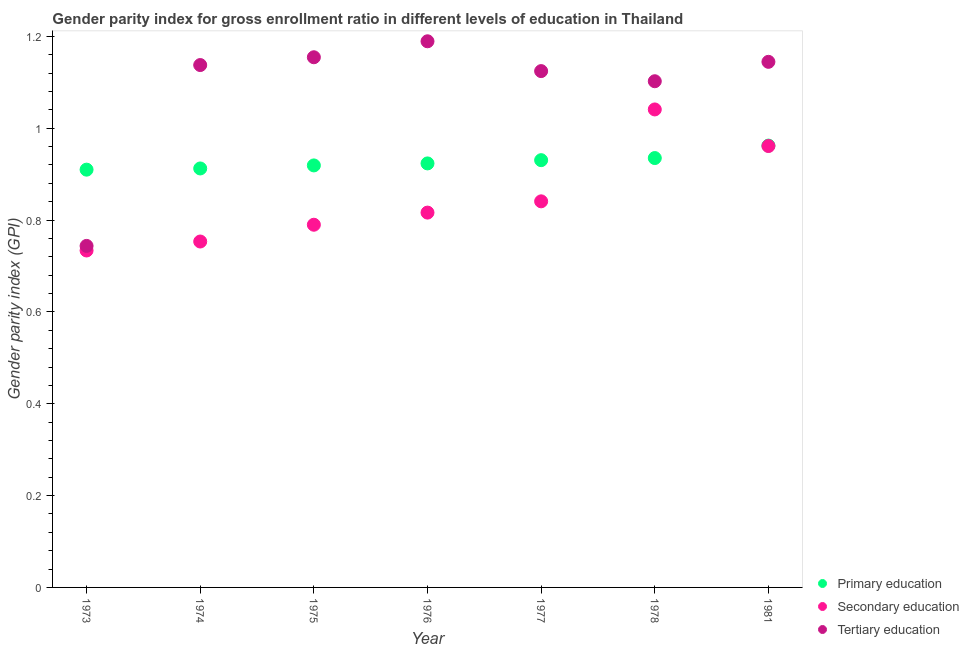How many different coloured dotlines are there?
Offer a very short reply. 3. What is the gender parity index in primary education in 1973?
Provide a succinct answer. 0.91. Across all years, what is the maximum gender parity index in primary education?
Provide a short and direct response. 0.96. Across all years, what is the minimum gender parity index in secondary education?
Offer a very short reply. 0.73. In which year was the gender parity index in primary education maximum?
Keep it short and to the point. 1981. In which year was the gender parity index in primary education minimum?
Provide a short and direct response. 1973. What is the total gender parity index in primary education in the graph?
Give a very brief answer. 6.49. What is the difference between the gender parity index in primary education in 1973 and that in 1977?
Provide a short and direct response. -0.02. What is the difference between the gender parity index in secondary education in 1976 and the gender parity index in primary education in 1973?
Your response must be concise. -0.09. What is the average gender parity index in secondary education per year?
Offer a terse response. 0.85. In the year 1976, what is the difference between the gender parity index in secondary education and gender parity index in tertiary education?
Offer a terse response. -0.37. What is the ratio of the gender parity index in secondary education in 1973 to that in 1978?
Ensure brevity in your answer.  0.7. Is the gender parity index in primary education in 1973 less than that in 1974?
Provide a short and direct response. Yes. What is the difference between the highest and the second highest gender parity index in secondary education?
Your answer should be compact. 0.08. What is the difference between the highest and the lowest gender parity index in tertiary education?
Give a very brief answer. 0.45. Is it the case that in every year, the sum of the gender parity index in primary education and gender parity index in secondary education is greater than the gender parity index in tertiary education?
Offer a terse response. Yes. Does the gender parity index in secondary education monotonically increase over the years?
Offer a very short reply. No. Is the gender parity index in secondary education strictly greater than the gender parity index in tertiary education over the years?
Your answer should be very brief. No. Is the gender parity index in primary education strictly less than the gender parity index in tertiary education over the years?
Your response must be concise. No. How many dotlines are there?
Make the answer very short. 3. What is the difference between two consecutive major ticks on the Y-axis?
Provide a succinct answer. 0.2. Are the values on the major ticks of Y-axis written in scientific E-notation?
Provide a short and direct response. No. Does the graph contain grids?
Make the answer very short. No. Where does the legend appear in the graph?
Make the answer very short. Bottom right. How are the legend labels stacked?
Keep it short and to the point. Vertical. What is the title of the graph?
Your response must be concise. Gender parity index for gross enrollment ratio in different levels of education in Thailand. What is the label or title of the Y-axis?
Offer a very short reply. Gender parity index (GPI). What is the Gender parity index (GPI) in Primary education in 1973?
Your answer should be compact. 0.91. What is the Gender parity index (GPI) of Secondary education in 1973?
Make the answer very short. 0.73. What is the Gender parity index (GPI) of Tertiary education in 1973?
Ensure brevity in your answer.  0.74. What is the Gender parity index (GPI) in Primary education in 1974?
Keep it short and to the point. 0.91. What is the Gender parity index (GPI) in Secondary education in 1974?
Ensure brevity in your answer.  0.75. What is the Gender parity index (GPI) in Tertiary education in 1974?
Give a very brief answer. 1.14. What is the Gender parity index (GPI) in Primary education in 1975?
Your answer should be very brief. 0.92. What is the Gender parity index (GPI) in Secondary education in 1975?
Provide a short and direct response. 0.79. What is the Gender parity index (GPI) of Tertiary education in 1975?
Offer a terse response. 1.15. What is the Gender parity index (GPI) in Primary education in 1976?
Make the answer very short. 0.92. What is the Gender parity index (GPI) of Secondary education in 1976?
Your answer should be compact. 0.82. What is the Gender parity index (GPI) in Tertiary education in 1976?
Keep it short and to the point. 1.19. What is the Gender parity index (GPI) of Primary education in 1977?
Offer a very short reply. 0.93. What is the Gender parity index (GPI) in Secondary education in 1977?
Offer a terse response. 0.84. What is the Gender parity index (GPI) of Tertiary education in 1977?
Provide a succinct answer. 1.12. What is the Gender parity index (GPI) of Primary education in 1978?
Make the answer very short. 0.94. What is the Gender parity index (GPI) of Secondary education in 1978?
Provide a succinct answer. 1.04. What is the Gender parity index (GPI) of Tertiary education in 1978?
Provide a succinct answer. 1.1. What is the Gender parity index (GPI) of Primary education in 1981?
Make the answer very short. 0.96. What is the Gender parity index (GPI) in Secondary education in 1981?
Give a very brief answer. 0.96. What is the Gender parity index (GPI) of Tertiary education in 1981?
Keep it short and to the point. 1.14. Across all years, what is the maximum Gender parity index (GPI) in Primary education?
Give a very brief answer. 0.96. Across all years, what is the maximum Gender parity index (GPI) in Secondary education?
Your response must be concise. 1.04. Across all years, what is the maximum Gender parity index (GPI) in Tertiary education?
Your answer should be very brief. 1.19. Across all years, what is the minimum Gender parity index (GPI) of Primary education?
Provide a succinct answer. 0.91. Across all years, what is the minimum Gender parity index (GPI) in Secondary education?
Your answer should be very brief. 0.73. Across all years, what is the minimum Gender parity index (GPI) of Tertiary education?
Provide a short and direct response. 0.74. What is the total Gender parity index (GPI) in Primary education in the graph?
Your answer should be compact. 6.49. What is the total Gender parity index (GPI) in Secondary education in the graph?
Your answer should be compact. 5.94. What is the total Gender parity index (GPI) in Tertiary education in the graph?
Offer a terse response. 7.6. What is the difference between the Gender parity index (GPI) of Primary education in 1973 and that in 1974?
Your answer should be compact. -0. What is the difference between the Gender parity index (GPI) in Secondary education in 1973 and that in 1974?
Ensure brevity in your answer.  -0.02. What is the difference between the Gender parity index (GPI) of Tertiary education in 1973 and that in 1974?
Ensure brevity in your answer.  -0.39. What is the difference between the Gender parity index (GPI) in Primary education in 1973 and that in 1975?
Offer a terse response. -0.01. What is the difference between the Gender parity index (GPI) of Secondary education in 1973 and that in 1975?
Provide a short and direct response. -0.06. What is the difference between the Gender parity index (GPI) of Tertiary education in 1973 and that in 1975?
Make the answer very short. -0.41. What is the difference between the Gender parity index (GPI) in Primary education in 1973 and that in 1976?
Keep it short and to the point. -0.01. What is the difference between the Gender parity index (GPI) of Secondary education in 1973 and that in 1976?
Provide a short and direct response. -0.08. What is the difference between the Gender parity index (GPI) in Tertiary education in 1973 and that in 1976?
Ensure brevity in your answer.  -0.45. What is the difference between the Gender parity index (GPI) of Primary education in 1973 and that in 1977?
Offer a very short reply. -0.02. What is the difference between the Gender parity index (GPI) in Secondary education in 1973 and that in 1977?
Your answer should be compact. -0.11. What is the difference between the Gender parity index (GPI) of Tertiary education in 1973 and that in 1977?
Ensure brevity in your answer.  -0.38. What is the difference between the Gender parity index (GPI) in Primary education in 1973 and that in 1978?
Provide a succinct answer. -0.03. What is the difference between the Gender parity index (GPI) in Secondary education in 1973 and that in 1978?
Your answer should be compact. -0.31. What is the difference between the Gender parity index (GPI) of Tertiary education in 1973 and that in 1978?
Offer a very short reply. -0.36. What is the difference between the Gender parity index (GPI) in Primary education in 1973 and that in 1981?
Your response must be concise. -0.05. What is the difference between the Gender parity index (GPI) of Secondary education in 1973 and that in 1981?
Give a very brief answer. -0.23. What is the difference between the Gender parity index (GPI) in Tertiary education in 1973 and that in 1981?
Ensure brevity in your answer.  -0.4. What is the difference between the Gender parity index (GPI) in Primary education in 1974 and that in 1975?
Offer a very short reply. -0.01. What is the difference between the Gender parity index (GPI) in Secondary education in 1974 and that in 1975?
Give a very brief answer. -0.04. What is the difference between the Gender parity index (GPI) of Tertiary education in 1974 and that in 1975?
Keep it short and to the point. -0.02. What is the difference between the Gender parity index (GPI) of Primary education in 1974 and that in 1976?
Your response must be concise. -0.01. What is the difference between the Gender parity index (GPI) in Secondary education in 1974 and that in 1976?
Your answer should be compact. -0.06. What is the difference between the Gender parity index (GPI) of Tertiary education in 1974 and that in 1976?
Your answer should be very brief. -0.05. What is the difference between the Gender parity index (GPI) of Primary education in 1974 and that in 1977?
Give a very brief answer. -0.02. What is the difference between the Gender parity index (GPI) of Secondary education in 1974 and that in 1977?
Offer a very short reply. -0.09. What is the difference between the Gender parity index (GPI) of Tertiary education in 1974 and that in 1977?
Provide a short and direct response. 0.01. What is the difference between the Gender parity index (GPI) of Primary education in 1974 and that in 1978?
Offer a terse response. -0.02. What is the difference between the Gender parity index (GPI) in Secondary education in 1974 and that in 1978?
Ensure brevity in your answer.  -0.29. What is the difference between the Gender parity index (GPI) in Tertiary education in 1974 and that in 1978?
Keep it short and to the point. 0.04. What is the difference between the Gender parity index (GPI) in Primary education in 1974 and that in 1981?
Ensure brevity in your answer.  -0.05. What is the difference between the Gender parity index (GPI) of Secondary education in 1974 and that in 1981?
Offer a very short reply. -0.21. What is the difference between the Gender parity index (GPI) of Tertiary education in 1974 and that in 1981?
Give a very brief answer. -0.01. What is the difference between the Gender parity index (GPI) in Primary education in 1975 and that in 1976?
Provide a succinct answer. -0. What is the difference between the Gender parity index (GPI) of Secondary education in 1975 and that in 1976?
Ensure brevity in your answer.  -0.03. What is the difference between the Gender parity index (GPI) in Tertiary education in 1975 and that in 1976?
Ensure brevity in your answer.  -0.03. What is the difference between the Gender parity index (GPI) in Primary education in 1975 and that in 1977?
Provide a short and direct response. -0.01. What is the difference between the Gender parity index (GPI) of Secondary education in 1975 and that in 1977?
Keep it short and to the point. -0.05. What is the difference between the Gender parity index (GPI) of Tertiary education in 1975 and that in 1977?
Offer a terse response. 0.03. What is the difference between the Gender parity index (GPI) in Primary education in 1975 and that in 1978?
Offer a terse response. -0.02. What is the difference between the Gender parity index (GPI) of Secondary education in 1975 and that in 1978?
Your answer should be compact. -0.25. What is the difference between the Gender parity index (GPI) of Tertiary education in 1975 and that in 1978?
Provide a succinct answer. 0.05. What is the difference between the Gender parity index (GPI) in Primary education in 1975 and that in 1981?
Offer a very short reply. -0.04. What is the difference between the Gender parity index (GPI) in Secondary education in 1975 and that in 1981?
Offer a very short reply. -0.17. What is the difference between the Gender parity index (GPI) of Tertiary education in 1975 and that in 1981?
Offer a terse response. 0.01. What is the difference between the Gender parity index (GPI) in Primary education in 1976 and that in 1977?
Provide a succinct answer. -0.01. What is the difference between the Gender parity index (GPI) in Secondary education in 1976 and that in 1977?
Make the answer very short. -0.02. What is the difference between the Gender parity index (GPI) of Tertiary education in 1976 and that in 1977?
Your answer should be compact. 0.06. What is the difference between the Gender parity index (GPI) of Primary education in 1976 and that in 1978?
Offer a very short reply. -0.01. What is the difference between the Gender parity index (GPI) in Secondary education in 1976 and that in 1978?
Offer a very short reply. -0.22. What is the difference between the Gender parity index (GPI) in Tertiary education in 1976 and that in 1978?
Offer a terse response. 0.09. What is the difference between the Gender parity index (GPI) of Primary education in 1976 and that in 1981?
Provide a succinct answer. -0.04. What is the difference between the Gender parity index (GPI) of Secondary education in 1976 and that in 1981?
Your answer should be compact. -0.14. What is the difference between the Gender parity index (GPI) of Tertiary education in 1976 and that in 1981?
Offer a very short reply. 0.04. What is the difference between the Gender parity index (GPI) in Primary education in 1977 and that in 1978?
Provide a short and direct response. -0. What is the difference between the Gender parity index (GPI) in Secondary education in 1977 and that in 1978?
Provide a short and direct response. -0.2. What is the difference between the Gender parity index (GPI) in Tertiary education in 1977 and that in 1978?
Your answer should be very brief. 0.02. What is the difference between the Gender parity index (GPI) of Primary education in 1977 and that in 1981?
Provide a succinct answer. -0.03. What is the difference between the Gender parity index (GPI) in Secondary education in 1977 and that in 1981?
Ensure brevity in your answer.  -0.12. What is the difference between the Gender parity index (GPI) of Tertiary education in 1977 and that in 1981?
Your answer should be very brief. -0.02. What is the difference between the Gender parity index (GPI) in Primary education in 1978 and that in 1981?
Make the answer very short. -0.03. What is the difference between the Gender parity index (GPI) of Secondary education in 1978 and that in 1981?
Provide a short and direct response. 0.08. What is the difference between the Gender parity index (GPI) of Tertiary education in 1978 and that in 1981?
Provide a short and direct response. -0.04. What is the difference between the Gender parity index (GPI) of Primary education in 1973 and the Gender parity index (GPI) of Secondary education in 1974?
Ensure brevity in your answer.  0.16. What is the difference between the Gender parity index (GPI) of Primary education in 1973 and the Gender parity index (GPI) of Tertiary education in 1974?
Ensure brevity in your answer.  -0.23. What is the difference between the Gender parity index (GPI) in Secondary education in 1973 and the Gender parity index (GPI) in Tertiary education in 1974?
Provide a succinct answer. -0.4. What is the difference between the Gender parity index (GPI) in Primary education in 1973 and the Gender parity index (GPI) in Secondary education in 1975?
Provide a short and direct response. 0.12. What is the difference between the Gender parity index (GPI) in Primary education in 1973 and the Gender parity index (GPI) in Tertiary education in 1975?
Ensure brevity in your answer.  -0.24. What is the difference between the Gender parity index (GPI) of Secondary education in 1973 and the Gender parity index (GPI) of Tertiary education in 1975?
Your answer should be compact. -0.42. What is the difference between the Gender parity index (GPI) in Primary education in 1973 and the Gender parity index (GPI) in Secondary education in 1976?
Keep it short and to the point. 0.09. What is the difference between the Gender parity index (GPI) in Primary education in 1973 and the Gender parity index (GPI) in Tertiary education in 1976?
Keep it short and to the point. -0.28. What is the difference between the Gender parity index (GPI) in Secondary education in 1973 and the Gender parity index (GPI) in Tertiary education in 1976?
Provide a short and direct response. -0.46. What is the difference between the Gender parity index (GPI) in Primary education in 1973 and the Gender parity index (GPI) in Secondary education in 1977?
Your response must be concise. 0.07. What is the difference between the Gender parity index (GPI) of Primary education in 1973 and the Gender parity index (GPI) of Tertiary education in 1977?
Provide a succinct answer. -0.21. What is the difference between the Gender parity index (GPI) of Secondary education in 1973 and the Gender parity index (GPI) of Tertiary education in 1977?
Provide a succinct answer. -0.39. What is the difference between the Gender parity index (GPI) in Primary education in 1973 and the Gender parity index (GPI) in Secondary education in 1978?
Give a very brief answer. -0.13. What is the difference between the Gender parity index (GPI) in Primary education in 1973 and the Gender parity index (GPI) in Tertiary education in 1978?
Keep it short and to the point. -0.19. What is the difference between the Gender parity index (GPI) in Secondary education in 1973 and the Gender parity index (GPI) in Tertiary education in 1978?
Offer a very short reply. -0.37. What is the difference between the Gender parity index (GPI) in Primary education in 1973 and the Gender parity index (GPI) in Secondary education in 1981?
Your answer should be very brief. -0.05. What is the difference between the Gender parity index (GPI) in Primary education in 1973 and the Gender parity index (GPI) in Tertiary education in 1981?
Ensure brevity in your answer.  -0.23. What is the difference between the Gender parity index (GPI) of Secondary education in 1973 and the Gender parity index (GPI) of Tertiary education in 1981?
Provide a succinct answer. -0.41. What is the difference between the Gender parity index (GPI) in Primary education in 1974 and the Gender parity index (GPI) in Secondary education in 1975?
Your response must be concise. 0.12. What is the difference between the Gender parity index (GPI) in Primary education in 1974 and the Gender parity index (GPI) in Tertiary education in 1975?
Make the answer very short. -0.24. What is the difference between the Gender parity index (GPI) of Secondary education in 1974 and the Gender parity index (GPI) of Tertiary education in 1975?
Offer a terse response. -0.4. What is the difference between the Gender parity index (GPI) in Primary education in 1974 and the Gender parity index (GPI) in Secondary education in 1976?
Your answer should be compact. 0.1. What is the difference between the Gender parity index (GPI) in Primary education in 1974 and the Gender parity index (GPI) in Tertiary education in 1976?
Make the answer very short. -0.28. What is the difference between the Gender parity index (GPI) of Secondary education in 1974 and the Gender parity index (GPI) of Tertiary education in 1976?
Keep it short and to the point. -0.44. What is the difference between the Gender parity index (GPI) of Primary education in 1974 and the Gender parity index (GPI) of Secondary education in 1977?
Your response must be concise. 0.07. What is the difference between the Gender parity index (GPI) of Primary education in 1974 and the Gender parity index (GPI) of Tertiary education in 1977?
Your answer should be very brief. -0.21. What is the difference between the Gender parity index (GPI) in Secondary education in 1974 and the Gender parity index (GPI) in Tertiary education in 1977?
Ensure brevity in your answer.  -0.37. What is the difference between the Gender parity index (GPI) in Primary education in 1974 and the Gender parity index (GPI) in Secondary education in 1978?
Offer a terse response. -0.13. What is the difference between the Gender parity index (GPI) in Primary education in 1974 and the Gender parity index (GPI) in Tertiary education in 1978?
Provide a short and direct response. -0.19. What is the difference between the Gender parity index (GPI) of Secondary education in 1974 and the Gender parity index (GPI) of Tertiary education in 1978?
Your answer should be very brief. -0.35. What is the difference between the Gender parity index (GPI) in Primary education in 1974 and the Gender parity index (GPI) in Secondary education in 1981?
Make the answer very short. -0.05. What is the difference between the Gender parity index (GPI) of Primary education in 1974 and the Gender parity index (GPI) of Tertiary education in 1981?
Your answer should be compact. -0.23. What is the difference between the Gender parity index (GPI) in Secondary education in 1974 and the Gender parity index (GPI) in Tertiary education in 1981?
Your response must be concise. -0.39. What is the difference between the Gender parity index (GPI) in Primary education in 1975 and the Gender parity index (GPI) in Secondary education in 1976?
Keep it short and to the point. 0.1. What is the difference between the Gender parity index (GPI) of Primary education in 1975 and the Gender parity index (GPI) of Tertiary education in 1976?
Offer a terse response. -0.27. What is the difference between the Gender parity index (GPI) of Secondary education in 1975 and the Gender parity index (GPI) of Tertiary education in 1976?
Offer a terse response. -0.4. What is the difference between the Gender parity index (GPI) of Primary education in 1975 and the Gender parity index (GPI) of Secondary education in 1977?
Offer a terse response. 0.08. What is the difference between the Gender parity index (GPI) in Primary education in 1975 and the Gender parity index (GPI) in Tertiary education in 1977?
Offer a very short reply. -0.21. What is the difference between the Gender parity index (GPI) of Secondary education in 1975 and the Gender parity index (GPI) of Tertiary education in 1977?
Offer a terse response. -0.33. What is the difference between the Gender parity index (GPI) of Primary education in 1975 and the Gender parity index (GPI) of Secondary education in 1978?
Offer a very short reply. -0.12. What is the difference between the Gender parity index (GPI) of Primary education in 1975 and the Gender parity index (GPI) of Tertiary education in 1978?
Offer a very short reply. -0.18. What is the difference between the Gender parity index (GPI) in Secondary education in 1975 and the Gender parity index (GPI) in Tertiary education in 1978?
Offer a terse response. -0.31. What is the difference between the Gender parity index (GPI) in Primary education in 1975 and the Gender parity index (GPI) in Secondary education in 1981?
Give a very brief answer. -0.04. What is the difference between the Gender parity index (GPI) of Primary education in 1975 and the Gender parity index (GPI) of Tertiary education in 1981?
Your answer should be very brief. -0.23. What is the difference between the Gender parity index (GPI) in Secondary education in 1975 and the Gender parity index (GPI) in Tertiary education in 1981?
Your answer should be very brief. -0.35. What is the difference between the Gender parity index (GPI) of Primary education in 1976 and the Gender parity index (GPI) of Secondary education in 1977?
Make the answer very short. 0.08. What is the difference between the Gender parity index (GPI) in Primary education in 1976 and the Gender parity index (GPI) in Tertiary education in 1977?
Your answer should be very brief. -0.2. What is the difference between the Gender parity index (GPI) in Secondary education in 1976 and the Gender parity index (GPI) in Tertiary education in 1977?
Provide a succinct answer. -0.31. What is the difference between the Gender parity index (GPI) in Primary education in 1976 and the Gender parity index (GPI) in Secondary education in 1978?
Offer a terse response. -0.12. What is the difference between the Gender parity index (GPI) in Primary education in 1976 and the Gender parity index (GPI) in Tertiary education in 1978?
Make the answer very short. -0.18. What is the difference between the Gender parity index (GPI) of Secondary education in 1976 and the Gender parity index (GPI) of Tertiary education in 1978?
Offer a terse response. -0.29. What is the difference between the Gender parity index (GPI) of Primary education in 1976 and the Gender parity index (GPI) of Secondary education in 1981?
Provide a succinct answer. -0.04. What is the difference between the Gender parity index (GPI) in Primary education in 1976 and the Gender parity index (GPI) in Tertiary education in 1981?
Offer a very short reply. -0.22. What is the difference between the Gender parity index (GPI) of Secondary education in 1976 and the Gender parity index (GPI) of Tertiary education in 1981?
Offer a terse response. -0.33. What is the difference between the Gender parity index (GPI) of Primary education in 1977 and the Gender parity index (GPI) of Secondary education in 1978?
Provide a succinct answer. -0.11. What is the difference between the Gender parity index (GPI) of Primary education in 1977 and the Gender parity index (GPI) of Tertiary education in 1978?
Your response must be concise. -0.17. What is the difference between the Gender parity index (GPI) in Secondary education in 1977 and the Gender parity index (GPI) in Tertiary education in 1978?
Provide a succinct answer. -0.26. What is the difference between the Gender parity index (GPI) in Primary education in 1977 and the Gender parity index (GPI) in Secondary education in 1981?
Offer a terse response. -0.03. What is the difference between the Gender parity index (GPI) of Primary education in 1977 and the Gender parity index (GPI) of Tertiary education in 1981?
Offer a very short reply. -0.21. What is the difference between the Gender parity index (GPI) in Secondary education in 1977 and the Gender parity index (GPI) in Tertiary education in 1981?
Offer a very short reply. -0.3. What is the difference between the Gender parity index (GPI) in Primary education in 1978 and the Gender parity index (GPI) in Secondary education in 1981?
Offer a terse response. -0.03. What is the difference between the Gender parity index (GPI) of Primary education in 1978 and the Gender parity index (GPI) of Tertiary education in 1981?
Your answer should be compact. -0.21. What is the difference between the Gender parity index (GPI) of Secondary education in 1978 and the Gender parity index (GPI) of Tertiary education in 1981?
Offer a very short reply. -0.1. What is the average Gender parity index (GPI) in Primary education per year?
Your answer should be very brief. 0.93. What is the average Gender parity index (GPI) of Secondary education per year?
Your answer should be very brief. 0.85. What is the average Gender parity index (GPI) of Tertiary education per year?
Your answer should be very brief. 1.09. In the year 1973, what is the difference between the Gender parity index (GPI) of Primary education and Gender parity index (GPI) of Secondary education?
Give a very brief answer. 0.18. In the year 1973, what is the difference between the Gender parity index (GPI) of Primary education and Gender parity index (GPI) of Tertiary education?
Your answer should be compact. 0.17. In the year 1973, what is the difference between the Gender parity index (GPI) of Secondary education and Gender parity index (GPI) of Tertiary education?
Your response must be concise. -0.01. In the year 1974, what is the difference between the Gender parity index (GPI) in Primary education and Gender parity index (GPI) in Secondary education?
Offer a very short reply. 0.16. In the year 1974, what is the difference between the Gender parity index (GPI) in Primary education and Gender parity index (GPI) in Tertiary education?
Your answer should be very brief. -0.23. In the year 1974, what is the difference between the Gender parity index (GPI) in Secondary education and Gender parity index (GPI) in Tertiary education?
Ensure brevity in your answer.  -0.38. In the year 1975, what is the difference between the Gender parity index (GPI) of Primary education and Gender parity index (GPI) of Secondary education?
Ensure brevity in your answer.  0.13. In the year 1975, what is the difference between the Gender parity index (GPI) of Primary education and Gender parity index (GPI) of Tertiary education?
Keep it short and to the point. -0.24. In the year 1975, what is the difference between the Gender parity index (GPI) in Secondary education and Gender parity index (GPI) in Tertiary education?
Your answer should be very brief. -0.36. In the year 1976, what is the difference between the Gender parity index (GPI) in Primary education and Gender parity index (GPI) in Secondary education?
Keep it short and to the point. 0.11. In the year 1976, what is the difference between the Gender parity index (GPI) in Primary education and Gender parity index (GPI) in Tertiary education?
Make the answer very short. -0.27. In the year 1976, what is the difference between the Gender parity index (GPI) of Secondary education and Gender parity index (GPI) of Tertiary education?
Offer a terse response. -0.37. In the year 1977, what is the difference between the Gender parity index (GPI) of Primary education and Gender parity index (GPI) of Secondary education?
Your answer should be very brief. 0.09. In the year 1977, what is the difference between the Gender parity index (GPI) of Primary education and Gender parity index (GPI) of Tertiary education?
Ensure brevity in your answer.  -0.19. In the year 1977, what is the difference between the Gender parity index (GPI) in Secondary education and Gender parity index (GPI) in Tertiary education?
Provide a succinct answer. -0.28. In the year 1978, what is the difference between the Gender parity index (GPI) in Primary education and Gender parity index (GPI) in Secondary education?
Provide a succinct answer. -0.11. In the year 1978, what is the difference between the Gender parity index (GPI) of Primary education and Gender parity index (GPI) of Tertiary education?
Offer a terse response. -0.17. In the year 1978, what is the difference between the Gender parity index (GPI) of Secondary education and Gender parity index (GPI) of Tertiary education?
Ensure brevity in your answer.  -0.06. In the year 1981, what is the difference between the Gender parity index (GPI) of Primary education and Gender parity index (GPI) of Secondary education?
Give a very brief answer. 0. In the year 1981, what is the difference between the Gender parity index (GPI) of Primary education and Gender parity index (GPI) of Tertiary education?
Keep it short and to the point. -0.18. In the year 1981, what is the difference between the Gender parity index (GPI) in Secondary education and Gender parity index (GPI) in Tertiary education?
Make the answer very short. -0.18. What is the ratio of the Gender parity index (GPI) of Secondary education in 1973 to that in 1974?
Offer a very short reply. 0.97. What is the ratio of the Gender parity index (GPI) of Tertiary education in 1973 to that in 1974?
Provide a succinct answer. 0.65. What is the ratio of the Gender parity index (GPI) of Primary education in 1973 to that in 1975?
Keep it short and to the point. 0.99. What is the ratio of the Gender parity index (GPI) of Secondary education in 1973 to that in 1975?
Offer a terse response. 0.93. What is the ratio of the Gender parity index (GPI) of Tertiary education in 1973 to that in 1975?
Give a very brief answer. 0.64. What is the ratio of the Gender parity index (GPI) in Primary education in 1973 to that in 1976?
Your response must be concise. 0.99. What is the ratio of the Gender parity index (GPI) in Secondary education in 1973 to that in 1976?
Keep it short and to the point. 0.9. What is the ratio of the Gender parity index (GPI) in Tertiary education in 1973 to that in 1976?
Offer a terse response. 0.63. What is the ratio of the Gender parity index (GPI) in Primary education in 1973 to that in 1977?
Ensure brevity in your answer.  0.98. What is the ratio of the Gender parity index (GPI) of Secondary education in 1973 to that in 1977?
Make the answer very short. 0.87. What is the ratio of the Gender parity index (GPI) in Tertiary education in 1973 to that in 1977?
Give a very brief answer. 0.66. What is the ratio of the Gender parity index (GPI) in Secondary education in 1973 to that in 1978?
Ensure brevity in your answer.  0.7. What is the ratio of the Gender parity index (GPI) in Tertiary education in 1973 to that in 1978?
Provide a succinct answer. 0.67. What is the ratio of the Gender parity index (GPI) in Primary education in 1973 to that in 1981?
Offer a very short reply. 0.95. What is the ratio of the Gender parity index (GPI) in Secondary education in 1973 to that in 1981?
Provide a succinct answer. 0.76. What is the ratio of the Gender parity index (GPI) in Tertiary education in 1973 to that in 1981?
Your answer should be very brief. 0.65. What is the ratio of the Gender parity index (GPI) in Primary education in 1974 to that in 1975?
Make the answer very short. 0.99. What is the ratio of the Gender parity index (GPI) of Secondary education in 1974 to that in 1975?
Provide a succinct answer. 0.95. What is the ratio of the Gender parity index (GPI) of Secondary education in 1974 to that in 1976?
Offer a terse response. 0.92. What is the ratio of the Gender parity index (GPI) in Tertiary education in 1974 to that in 1976?
Offer a very short reply. 0.96. What is the ratio of the Gender parity index (GPI) in Primary education in 1974 to that in 1977?
Offer a terse response. 0.98. What is the ratio of the Gender parity index (GPI) in Secondary education in 1974 to that in 1977?
Give a very brief answer. 0.9. What is the ratio of the Gender parity index (GPI) in Tertiary education in 1974 to that in 1977?
Provide a succinct answer. 1.01. What is the ratio of the Gender parity index (GPI) in Primary education in 1974 to that in 1978?
Offer a very short reply. 0.98. What is the ratio of the Gender parity index (GPI) in Secondary education in 1974 to that in 1978?
Provide a succinct answer. 0.72. What is the ratio of the Gender parity index (GPI) of Tertiary education in 1974 to that in 1978?
Your answer should be compact. 1.03. What is the ratio of the Gender parity index (GPI) of Primary education in 1974 to that in 1981?
Ensure brevity in your answer.  0.95. What is the ratio of the Gender parity index (GPI) of Secondary education in 1974 to that in 1981?
Ensure brevity in your answer.  0.78. What is the ratio of the Gender parity index (GPI) of Tertiary education in 1974 to that in 1981?
Provide a short and direct response. 0.99. What is the ratio of the Gender parity index (GPI) in Secondary education in 1975 to that in 1976?
Offer a terse response. 0.97. What is the ratio of the Gender parity index (GPI) of Tertiary education in 1975 to that in 1976?
Your response must be concise. 0.97. What is the ratio of the Gender parity index (GPI) in Secondary education in 1975 to that in 1977?
Your response must be concise. 0.94. What is the ratio of the Gender parity index (GPI) of Tertiary education in 1975 to that in 1977?
Provide a short and direct response. 1.03. What is the ratio of the Gender parity index (GPI) in Primary education in 1975 to that in 1978?
Your answer should be very brief. 0.98. What is the ratio of the Gender parity index (GPI) in Secondary education in 1975 to that in 1978?
Keep it short and to the point. 0.76. What is the ratio of the Gender parity index (GPI) of Tertiary education in 1975 to that in 1978?
Your response must be concise. 1.05. What is the ratio of the Gender parity index (GPI) of Primary education in 1975 to that in 1981?
Your answer should be very brief. 0.96. What is the ratio of the Gender parity index (GPI) of Secondary education in 1975 to that in 1981?
Give a very brief answer. 0.82. What is the ratio of the Gender parity index (GPI) of Tertiary education in 1975 to that in 1981?
Your answer should be very brief. 1.01. What is the ratio of the Gender parity index (GPI) in Secondary education in 1976 to that in 1977?
Your answer should be compact. 0.97. What is the ratio of the Gender parity index (GPI) in Tertiary education in 1976 to that in 1977?
Offer a very short reply. 1.06. What is the ratio of the Gender parity index (GPI) of Primary education in 1976 to that in 1978?
Your answer should be compact. 0.99. What is the ratio of the Gender parity index (GPI) in Secondary education in 1976 to that in 1978?
Ensure brevity in your answer.  0.78. What is the ratio of the Gender parity index (GPI) of Tertiary education in 1976 to that in 1978?
Your response must be concise. 1.08. What is the ratio of the Gender parity index (GPI) in Primary education in 1976 to that in 1981?
Offer a terse response. 0.96. What is the ratio of the Gender parity index (GPI) of Secondary education in 1976 to that in 1981?
Keep it short and to the point. 0.85. What is the ratio of the Gender parity index (GPI) in Tertiary education in 1976 to that in 1981?
Offer a terse response. 1.04. What is the ratio of the Gender parity index (GPI) in Secondary education in 1977 to that in 1978?
Your answer should be very brief. 0.81. What is the ratio of the Gender parity index (GPI) of Tertiary education in 1977 to that in 1978?
Offer a terse response. 1.02. What is the ratio of the Gender parity index (GPI) in Primary education in 1977 to that in 1981?
Your answer should be compact. 0.97. What is the ratio of the Gender parity index (GPI) of Secondary education in 1977 to that in 1981?
Ensure brevity in your answer.  0.87. What is the ratio of the Gender parity index (GPI) in Tertiary education in 1977 to that in 1981?
Offer a terse response. 0.98. What is the ratio of the Gender parity index (GPI) in Primary education in 1978 to that in 1981?
Give a very brief answer. 0.97. What is the ratio of the Gender parity index (GPI) of Secondary education in 1978 to that in 1981?
Make the answer very short. 1.08. What is the ratio of the Gender parity index (GPI) in Tertiary education in 1978 to that in 1981?
Give a very brief answer. 0.96. What is the difference between the highest and the second highest Gender parity index (GPI) of Primary education?
Your answer should be compact. 0.03. What is the difference between the highest and the second highest Gender parity index (GPI) of Secondary education?
Offer a very short reply. 0.08. What is the difference between the highest and the second highest Gender parity index (GPI) of Tertiary education?
Provide a short and direct response. 0.03. What is the difference between the highest and the lowest Gender parity index (GPI) in Primary education?
Your response must be concise. 0.05. What is the difference between the highest and the lowest Gender parity index (GPI) of Secondary education?
Your response must be concise. 0.31. What is the difference between the highest and the lowest Gender parity index (GPI) in Tertiary education?
Your answer should be very brief. 0.45. 